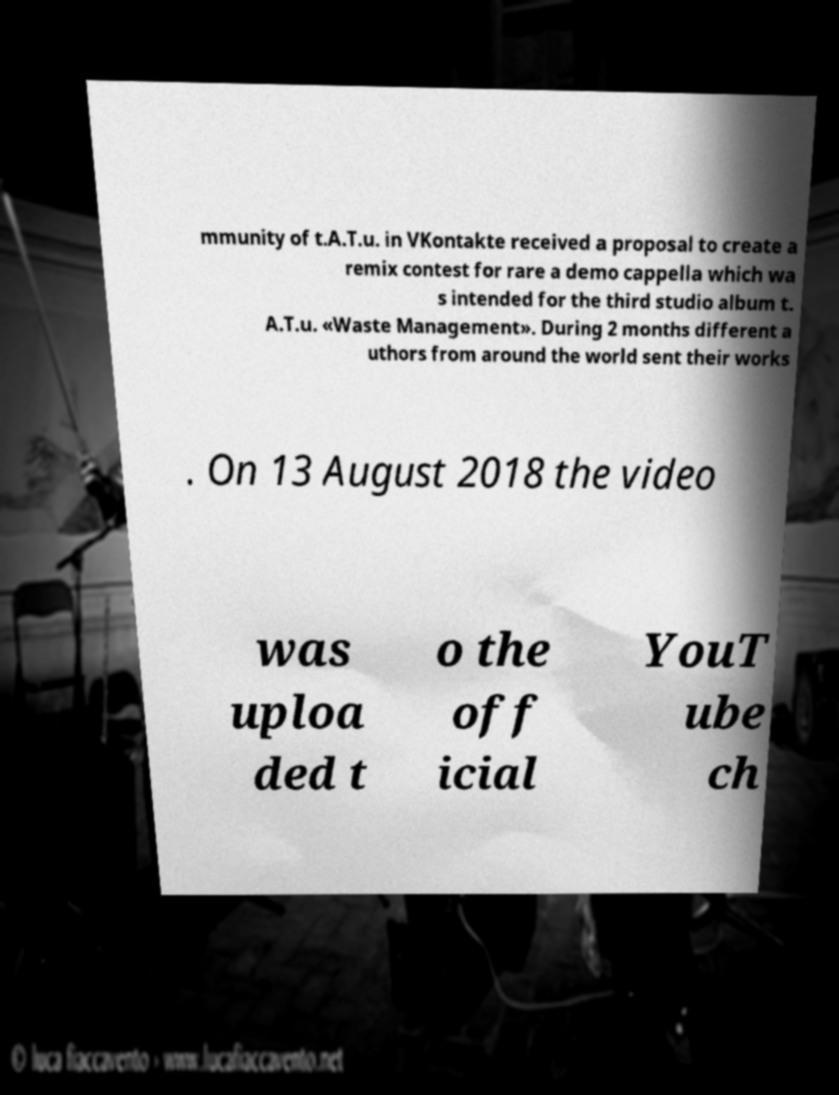Please identify and transcribe the text found in this image. mmunity of t.A.T.u. in VKontakte received a proposal to create a remix contest for rare a demo cappella which wa s intended for the third studio album t. A.T.u. «Waste Management». During 2 months different a uthors from around the world sent their works . On 13 August 2018 the video was uploa ded t o the off icial YouT ube ch 